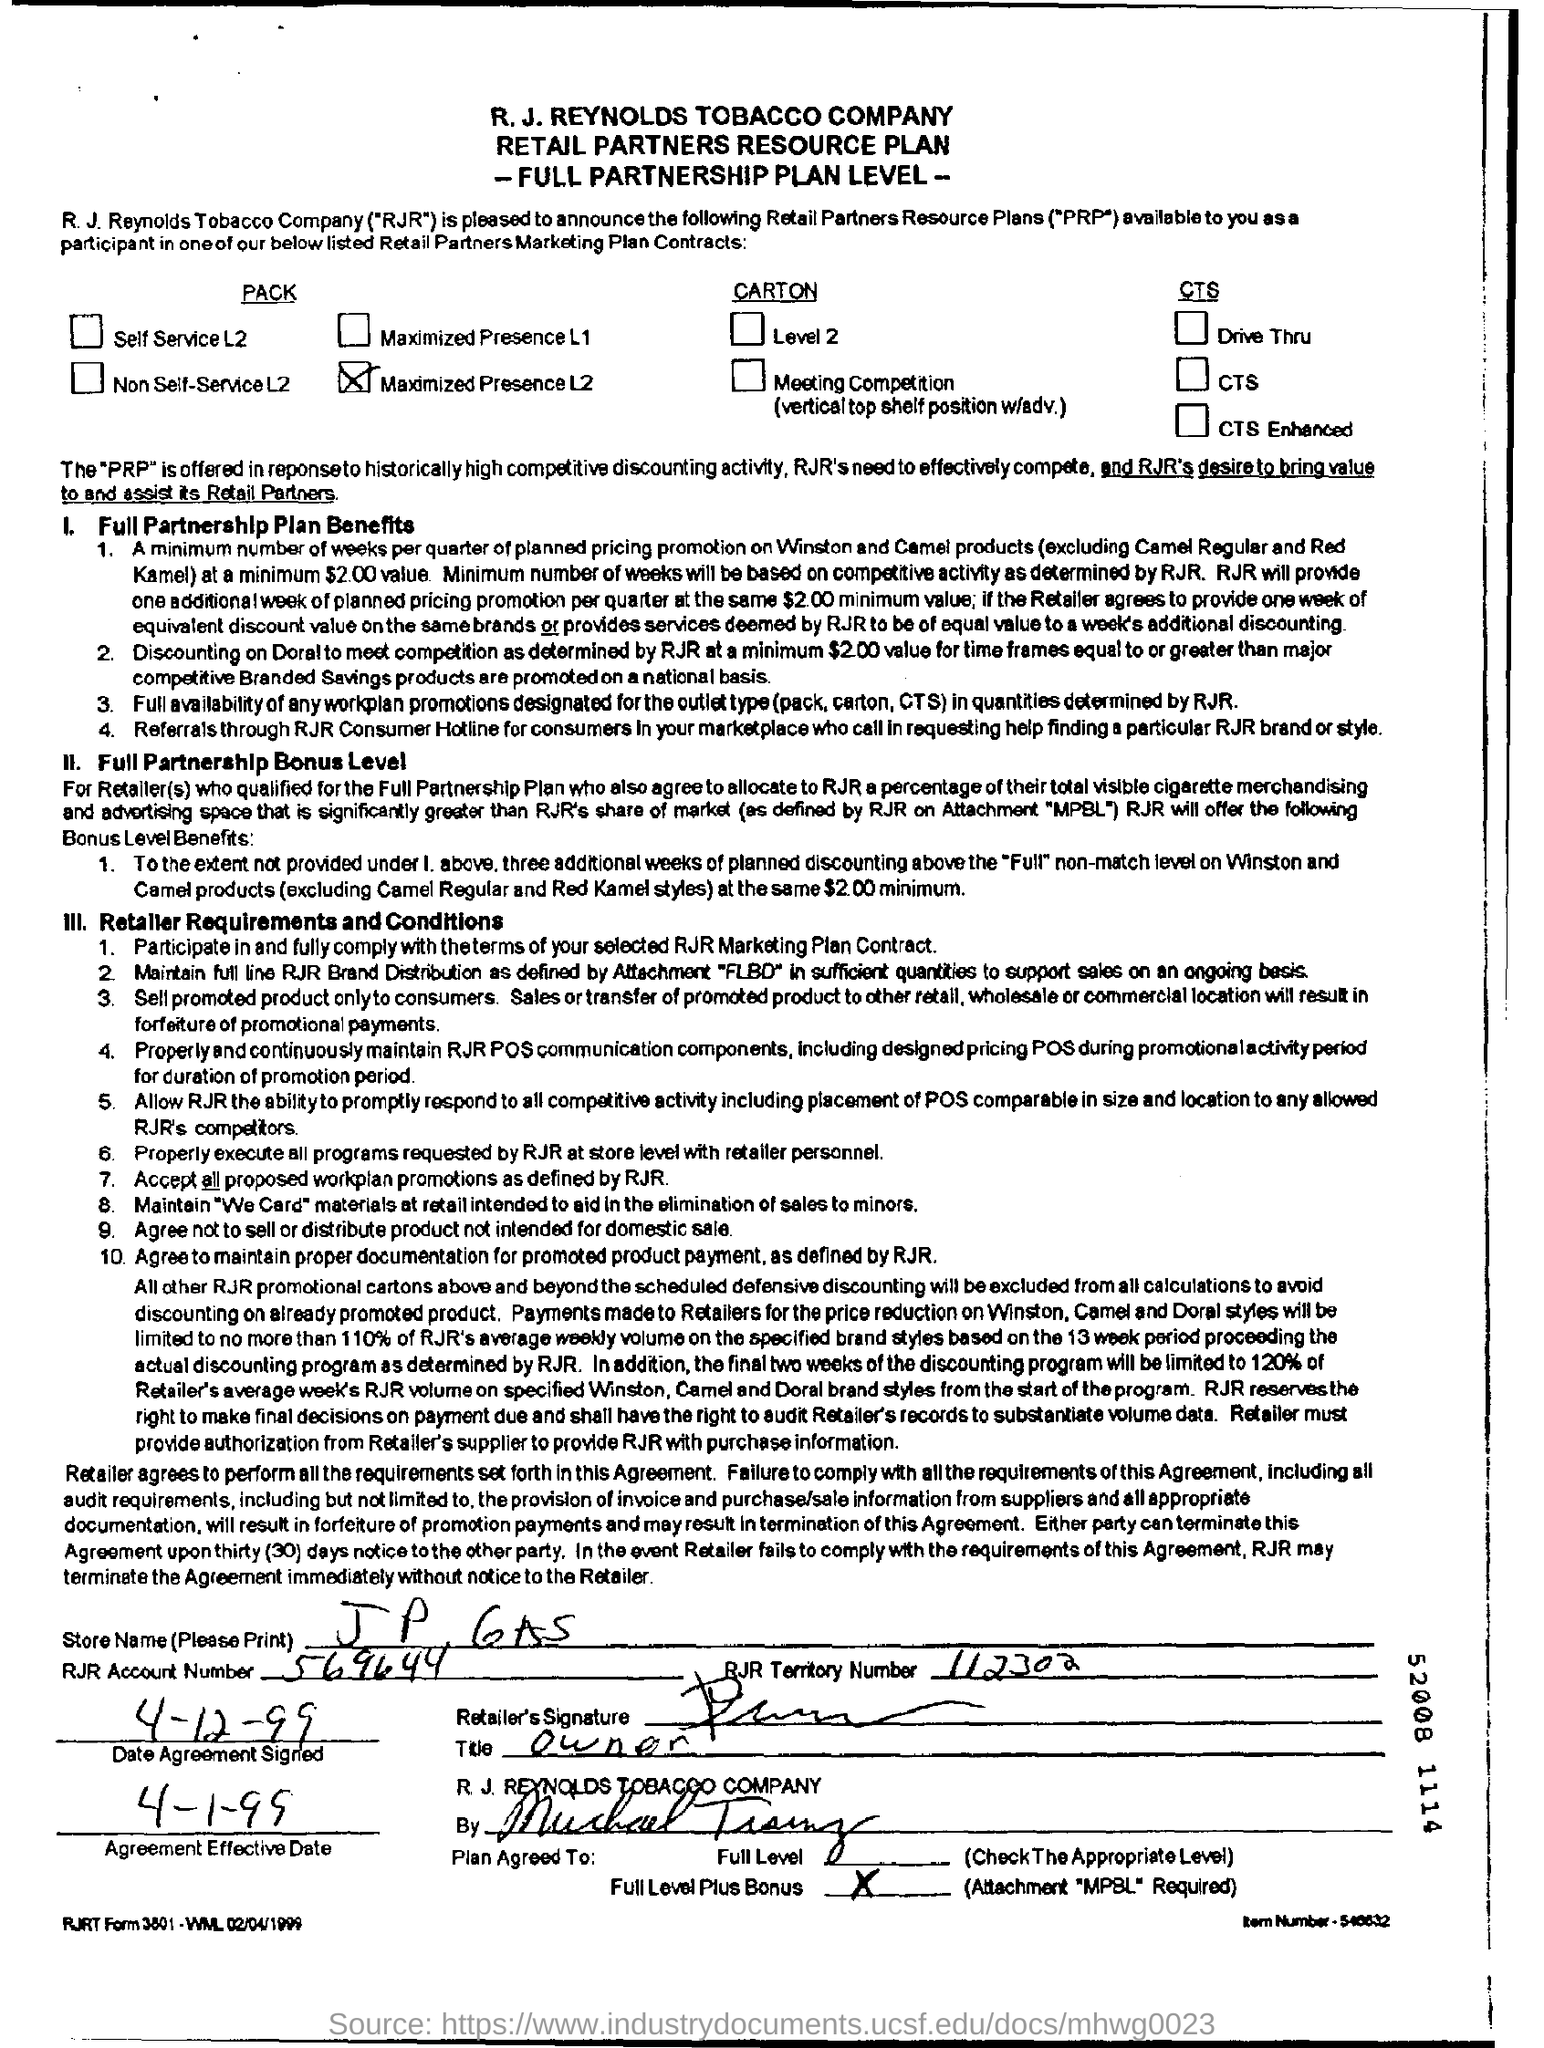What is the RJR Territory Number?
Ensure brevity in your answer.  112302. What is the Store Name ?
Keep it short and to the point. J P 6AS. What is the Agreement Effective Date?
Offer a very short reply. 4-1-99. What is the RJR Account Number ?
Give a very brief answer. 569644. What is the RJR account no given in the form?
Your answer should be very brief. 569644. 